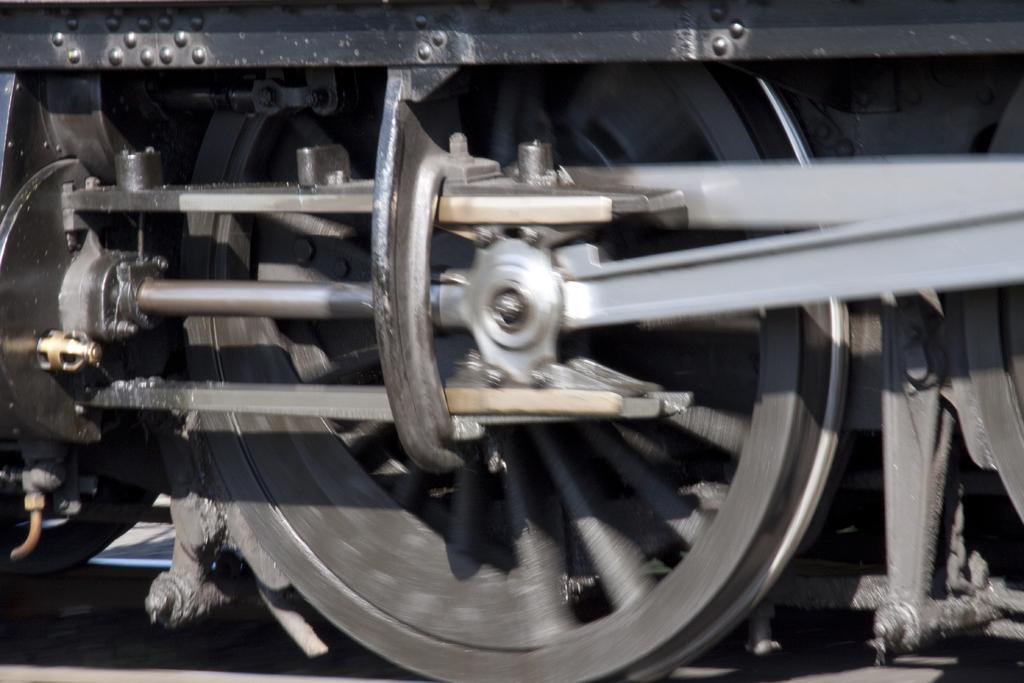What is the main subject of the image? The main subject of the image is a wheel of a train. Can you describe the wheel in more detail? The wheel appears to be large and metallic, with a circular shape and spokes radiating from the center. What might be the purpose of this wheel in the context of a train? The wheel is likely used for propulsion and support as the train moves along its tracks. What type of disease is depicted in the image? There is no disease depicted in the image; it features a wheel of a train. Can you describe the tail of the animal in the image? There is no animal or tail present in the image; it only shows a wheel of a train. 